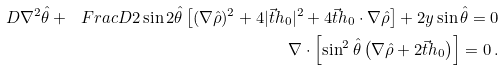Convert formula to latex. <formula><loc_0><loc_0><loc_500><loc_500>D \nabla ^ { 2 } \hat { \theta } + \ F r a c { D } { 2 } \sin 2 \hat { \theta } \left [ ( \nabla \hat { \rho } ) ^ { 2 } + 4 | \vec { t } { h } _ { 0 } | ^ { 2 } + 4 \vec { t } { h } _ { 0 } \cdot \nabla \hat { \rho } \right ] + 2 y \sin \hat { \theta } = 0 \\ \nabla \cdot \left [ \sin ^ { 2 } \hat { \theta } \left ( \nabla \hat { \rho } + 2 \vec { t } { h } _ { 0 } \right ) \right ] = 0 \, .</formula> 